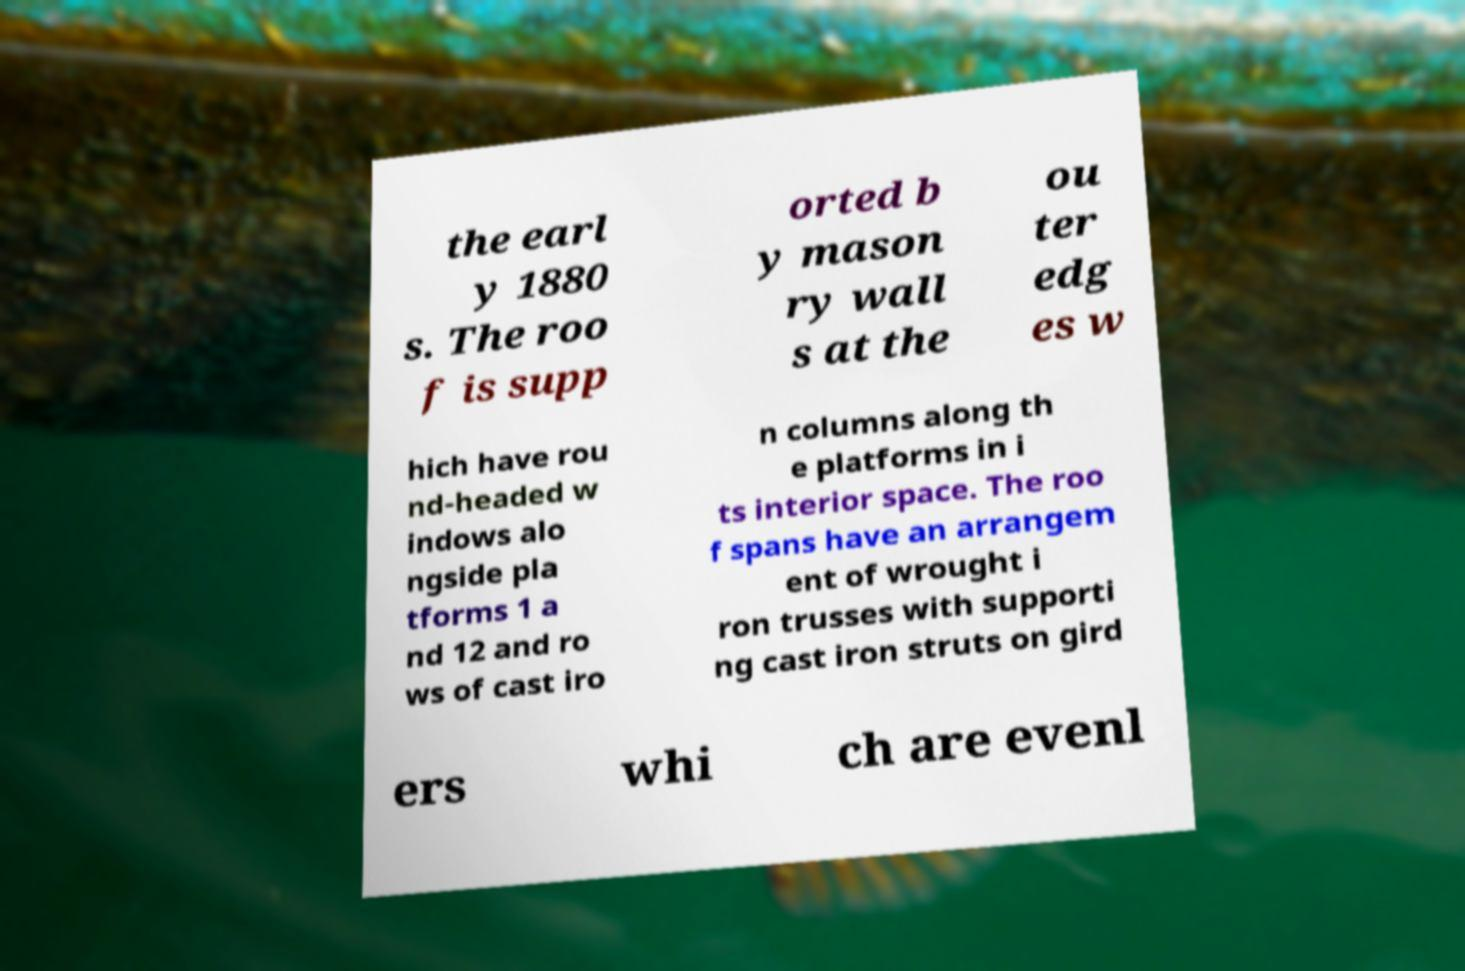Can you read and provide the text displayed in the image?This photo seems to have some interesting text. Can you extract and type it out for me? the earl y 1880 s. The roo f is supp orted b y mason ry wall s at the ou ter edg es w hich have rou nd-headed w indows alo ngside pla tforms 1 a nd 12 and ro ws of cast iro n columns along th e platforms in i ts interior space. The roo f spans have an arrangem ent of wrought i ron trusses with supporti ng cast iron struts on gird ers whi ch are evenl 